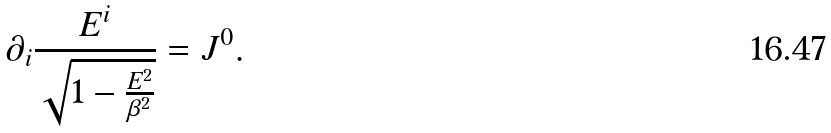Convert formula to latex. <formula><loc_0><loc_0><loc_500><loc_500>\partial _ { i } \frac { E ^ { i } } { { \sqrt { 1 - \frac { { { E } ^ { 2 } } } { \beta ^ { 2 } } } } } = J ^ { 0 } .</formula> 